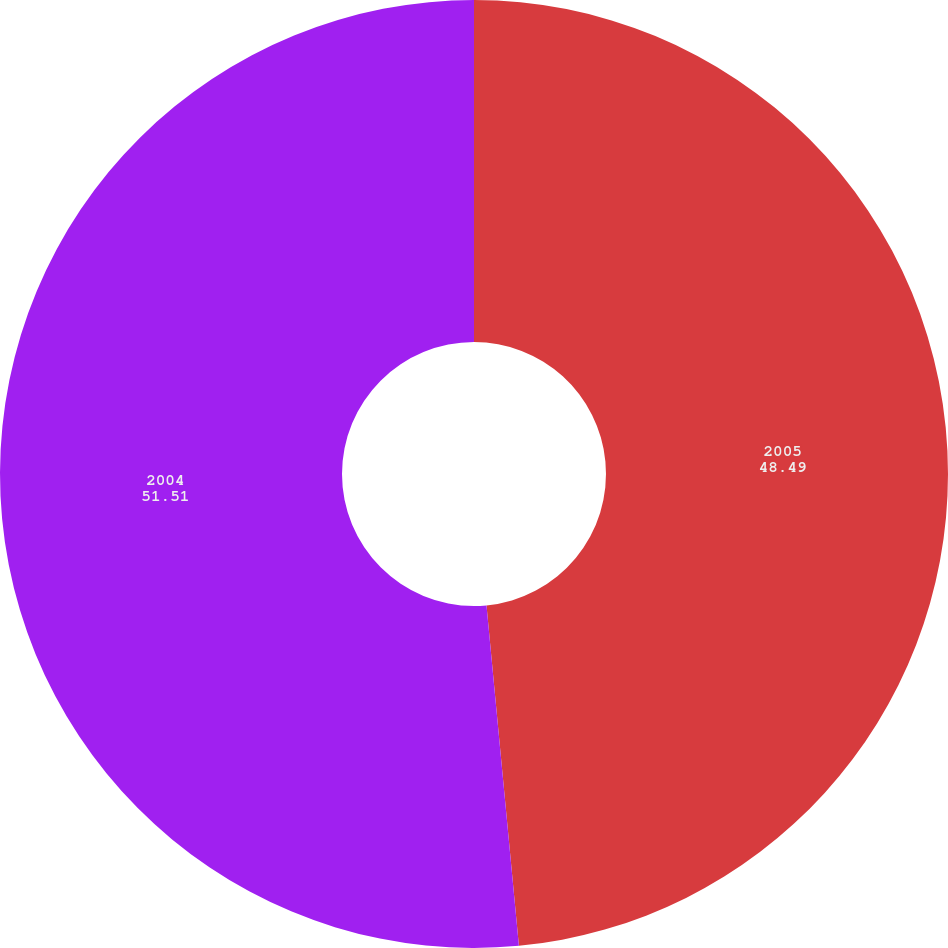<chart> <loc_0><loc_0><loc_500><loc_500><pie_chart><fcel>2005<fcel>2004<nl><fcel>48.49%<fcel>51.51%<nl></chart> 